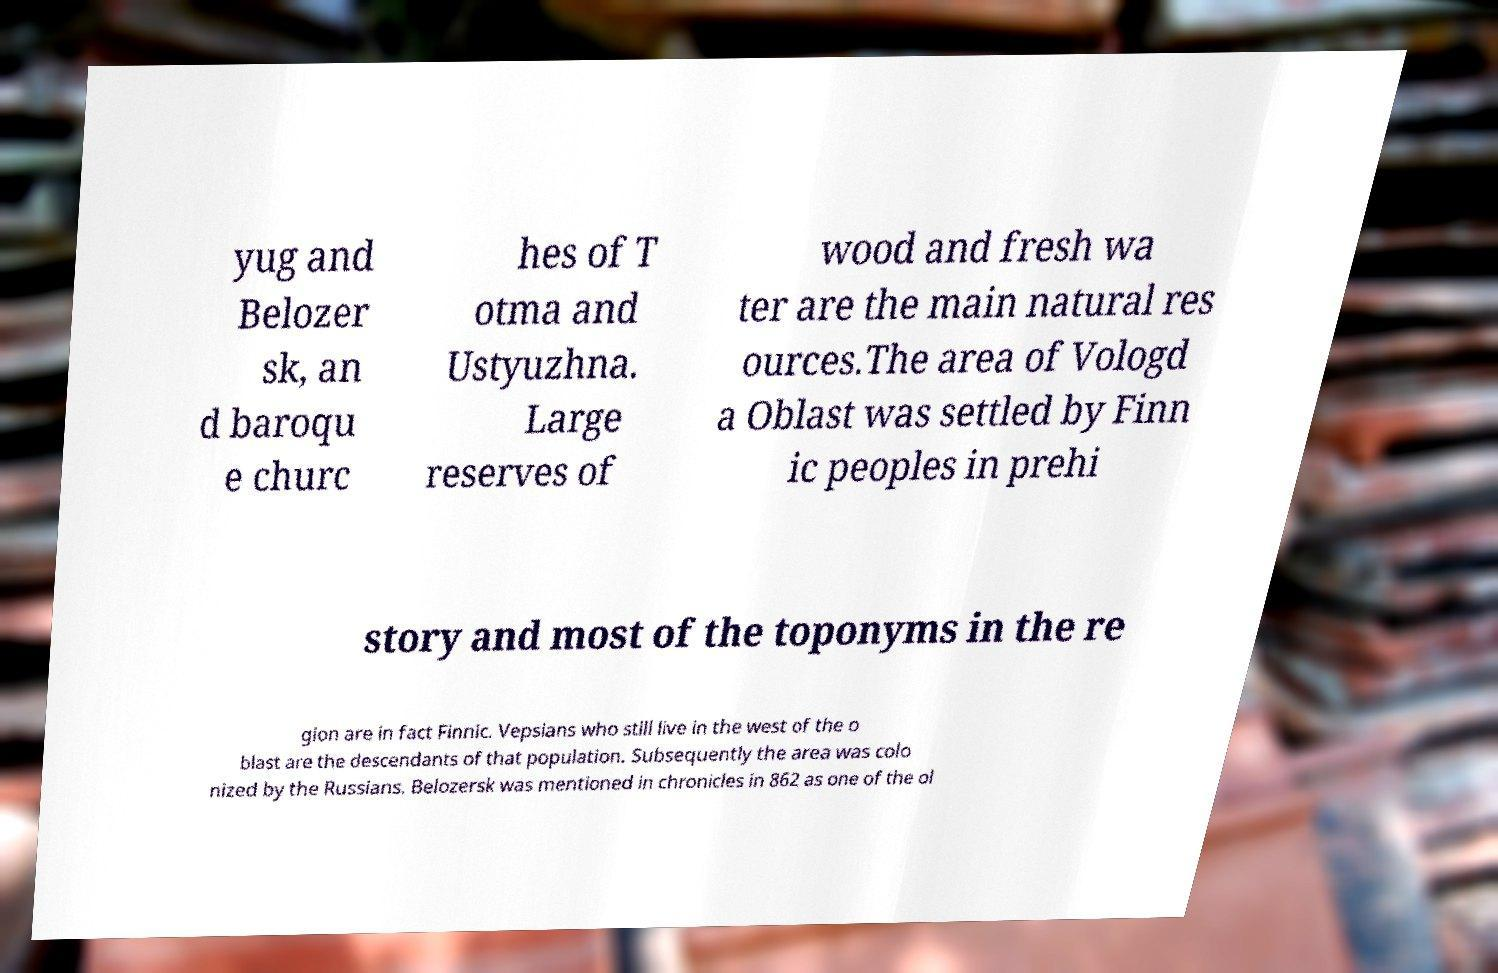I need the written content from this picture converted into text. Can you do that? yug and Belozer sk, an d baroqu e churc hes of T otma and Ustyuzhna. Large reserves of wood and fresh wa ter are the main natural res ources.The area of Vologd a Oblast was settled by Finn ic peoples in prehi story and most of the toponyms in the re gion are in fact Finnic. Vepsians who still live in the west of the o blast are the descendants of that population. Subsequently the area was colo nized by the Russians. Belozersk was mentioned in chronicles in 862 as one of the ol 